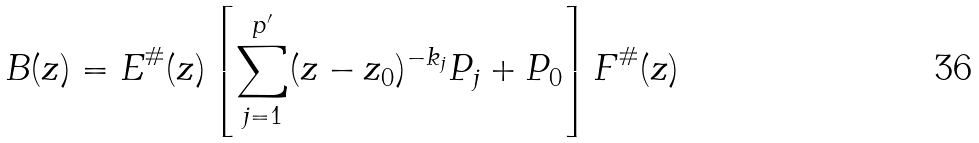<formula> <loc_0><loc_0><loc_500><loc_500>B ( z ) = E ^ { \# } ( z ) \left [ \sum _ { j = 1 } ^ { p ^ { \prime } } ( z - z _ { 0 } ) ^ { - k _ { j } } P _ { j } + P _ { 0 } \right ] F ^ { \# } ( z )</formula> 